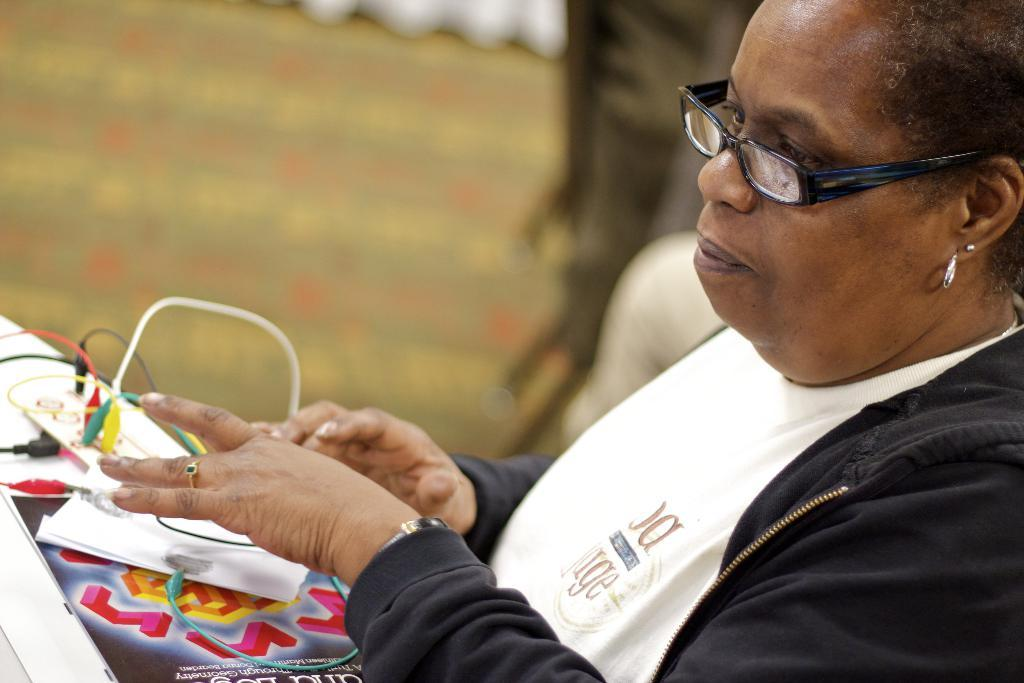Who is present in the image? There is a woman in the image. Where is the woman located in the image? The woman is on the right side of the image. What is the woman wearing in the image? The woman is wearing a black color jacket. What other items can be seen in the image? There are adapter cables and a design paper in the image. Where is the design paper located in the image? The design paper is on the left side of the image. What type of slope can be seen in the image? There is no slope present in the image. What is the woman's desire in the image? The image does not provide information about the woman's desires or emotions. 